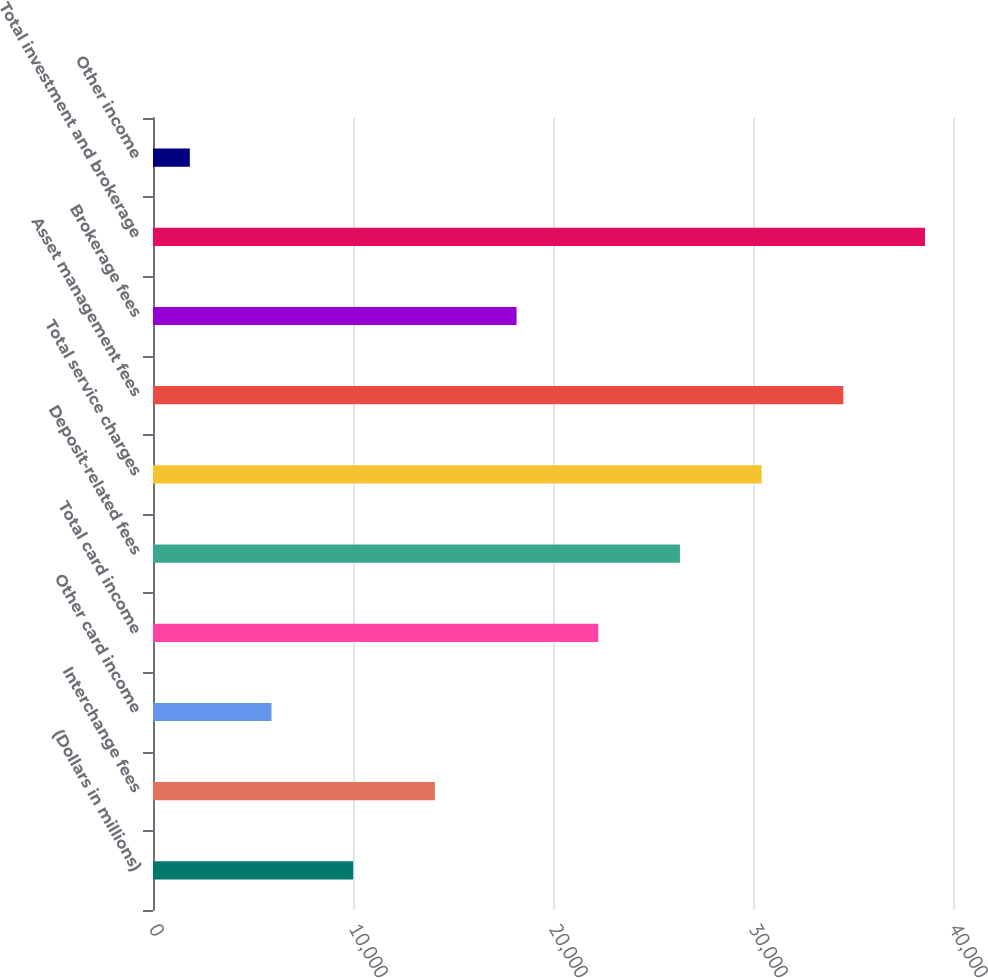Convert chart. <chart><loc_0><loc_0><loc_500><loc_500><bar_chart><fcel>(Dollars in millions)<fcel>Interchange fees<fcel>Other card income<fcel>Total card income<fcel>Deposit-related fees<fcel>Total service charges<fcel>Asset management fees<fcel>Brokerage fees<fcel>Total investment and brokerage<fcel>Other income<nl><fcel>10009.8<fcel>14094.2<fcel>5925.4<fcel>22263<fcel>26347.4<fcel>30431.8<fcel>34516.2<fcel>18178.6<fcel>38600.6<fcel>1841<nl></chart> 